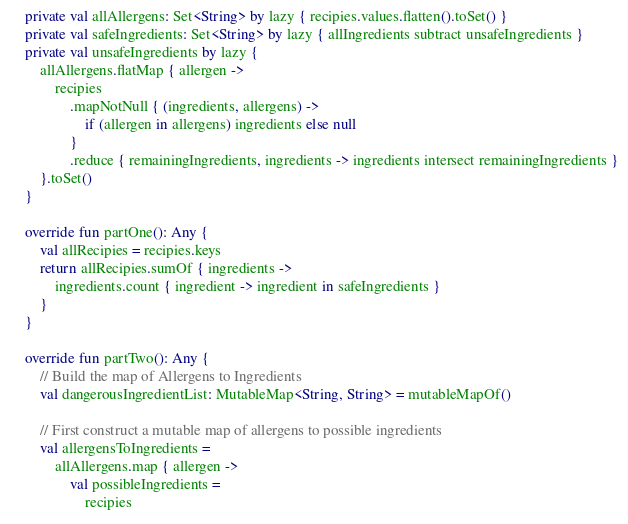<code> <loc_0><loc_0><loc_500><loc_500><_Kotlin_>    private val allAllergens: Set<String> by lazy { recipies.values.flatten().toSet() }
    private val safeIngredients: Set<String> by lazy { allIngredients subtract unsafeIngredients }
    private val unsafeIngredients by lazy {
        allAllergens.flatMap { allergen ->
            recipies
                .mapNotNull { (ingredients, allergens) ->
                    if (allergen in allergens) ingredients else null
                }
                .reduce { remainingIngredients, ingredients -> ingredients intersect remainingIngredients }
        }.toSet()
    }

    override fun partOne(): Any {
        val allRecipies = recipies.keys
        return allRecipies.sumOf { ingredients ->
            ingredients.count { ingredient -> ingredient in safeIngredients }
        }
    }

    override fun partTwo(): Any {
        // Build the map of Allergens to Ingredients
        val dangerousIngredientList: MutableMap<String, String> = mutableMapOf()

        // First construct a mutable map of allergens to possible ingredients
        val allergensToIngredients =
            allAllergens.map { allergen ->
                val possibleIngredients =
                    recipies</code> 